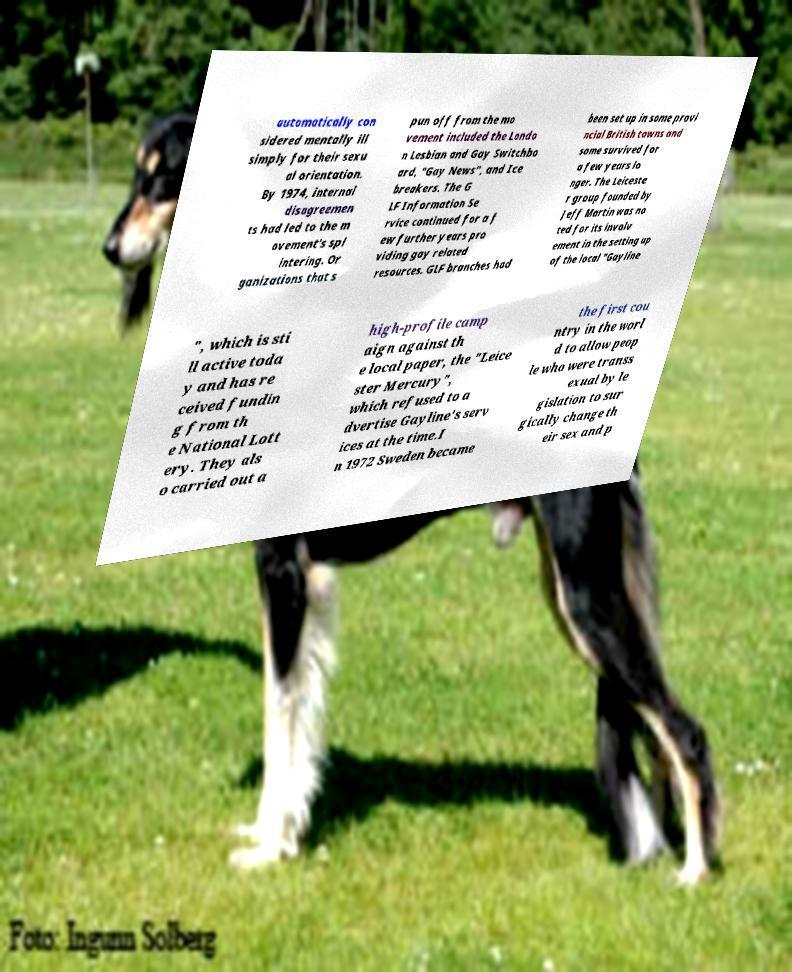I need the written content from this picture converted into text. Can you do that? automatically con sidered mentally ill simply for their sexu al orientation. By 1974, internal disagreemen ts had led to the m ovement's spl intering. Or ganizations that s pun off from the mo vement included the Londo n Lesbian and Gay Switchbo ard, "Gay News", and Ice breakers. The G LF Information Se rvice continued for a f ew further years pro viding gay related resources. GLF branches had been set up in some provi ncial British towns and some survived for a few years lo nger. The Leiceste r group founded by Jeff Martin was no ted for its involv ement in the setting up of the local "Gayline ", which is sti ll active toda y and has re ceived fundin g from th e National Lott ery. They als o carried out a high-profile camp aign against th e local paper, the "Leice ster Mercury", which refused to a dvertise Gayline's serv ices at the time.I n 1972 Sweden became the first cou ntry in the worl d to allow peop le who were transs exual by le gislation to sur gically change th eir sex and p 